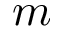<formula> <loc_0><loc_0><loc_500><loc_500>m</formula> 